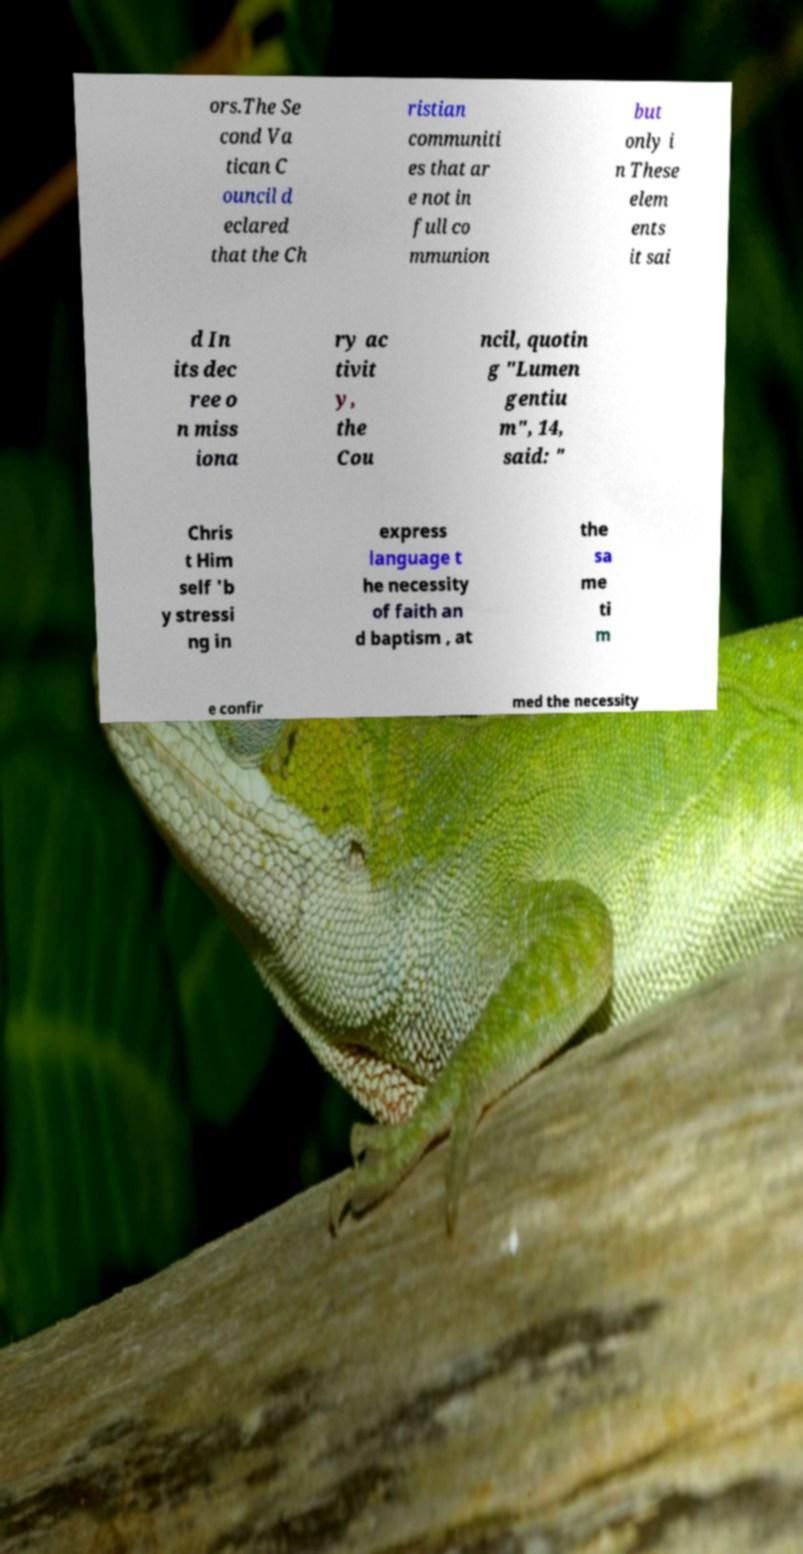Could you assist in decoding the text presented in this image and type it out clearly? ors.The Se cond Va tican C ouncil d eclared that the Ch ristian communiti es that ar e not in full co mmunion but only i n These elem ents it sai d In its dec ree o n miss iona ry ac tivit y, the Cou ncil, quotin g "Lumen gentiu m", 14, said: " Chris t Him self 'b y stressi ng in express language t he necessity of faith an d baptism , at the sa me ti m e confir med the necessity 